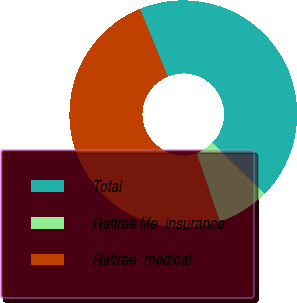Convert chart to OTSL. <chart><loc_0><loc_0><loc_500><loc_500><pie_chart><fcel>Total<fcel>Retiree life  insurance<fcel>Retiree  medical<nl><fcel>43.53%<fcel>7.46%<fcel>49.01%<nl></chart> 